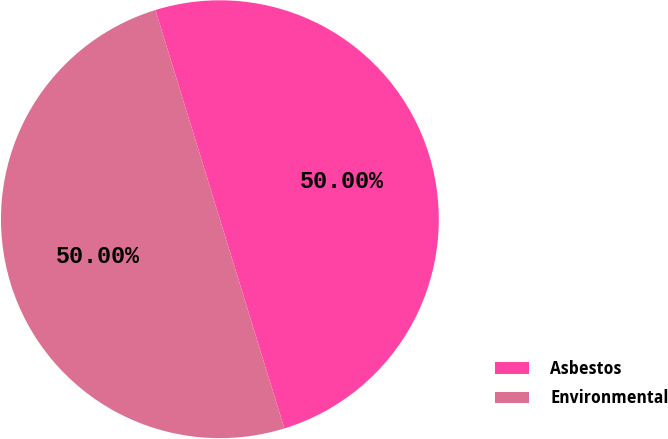Convert chart. <chart><loc_0><loc_0><loc_500><loc_500><pie_chart><fcel>Asbestos<fcel>Environmental<nl><fcel>50.0%<fcel>50.0%<nl></chart> 